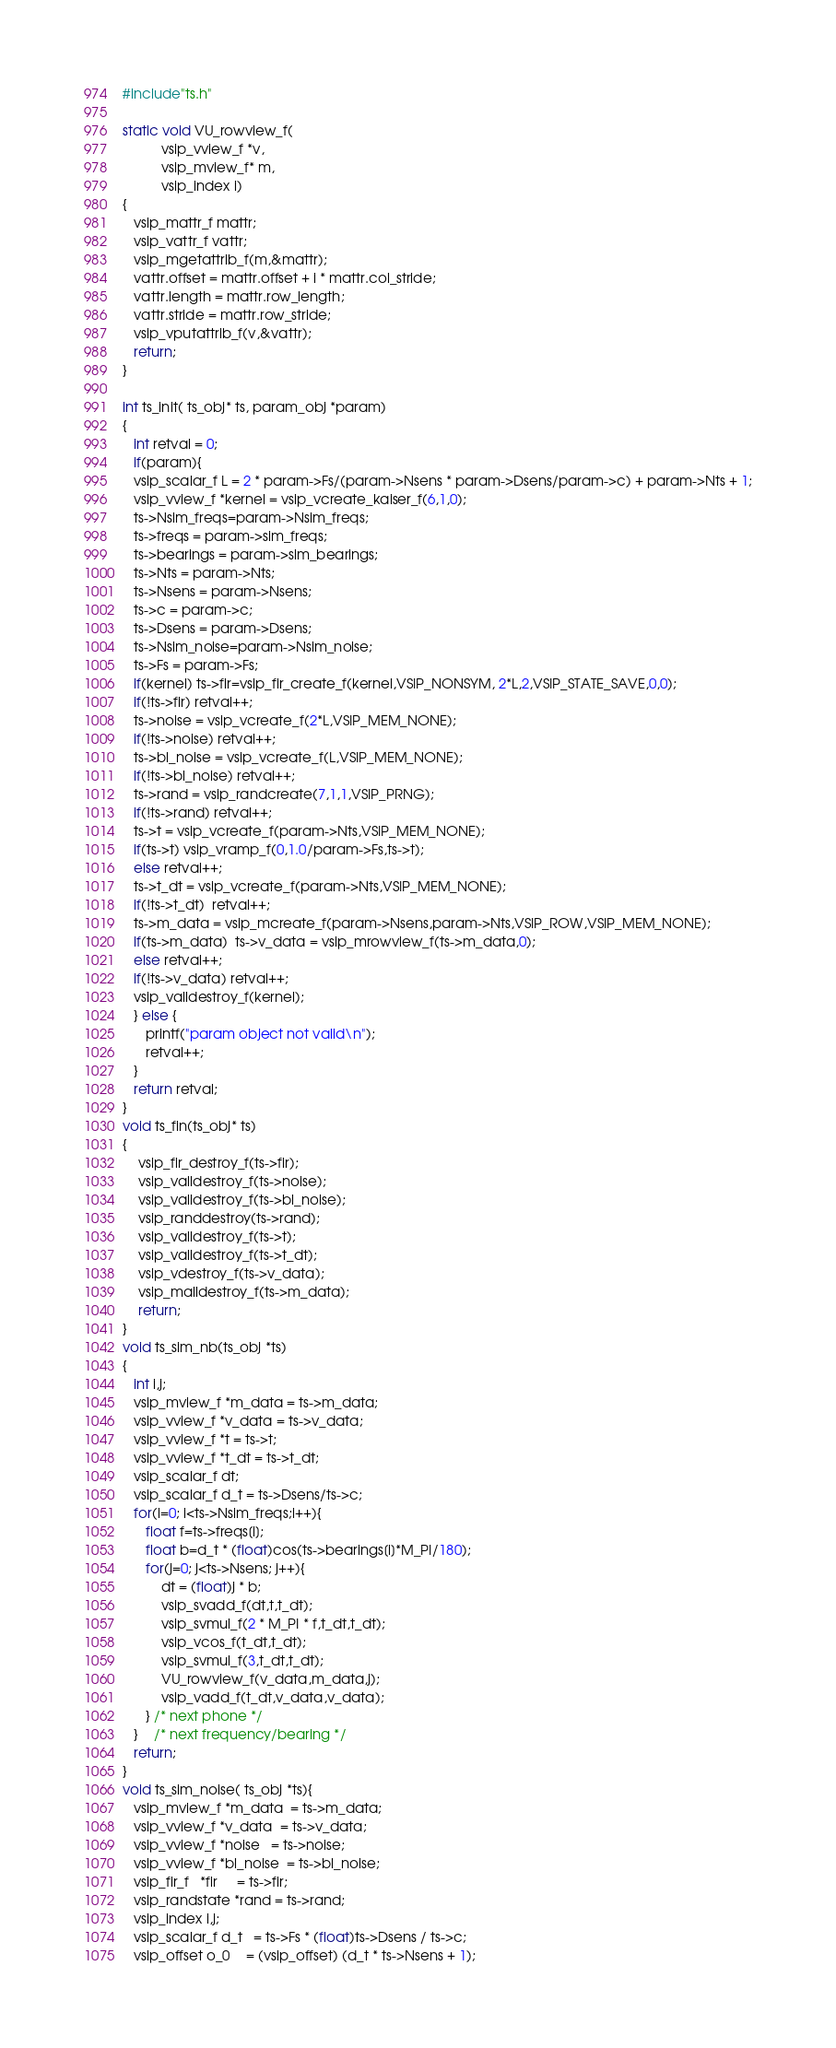Convert code to text. <code><loc_0><loc_0><loc_500><loc_500><_C_>#include"ts.h"

static void VU_rowview_f(
          vsip_vview_f *v, 
          vsip_mview_f* m, 
          vsip_index i)
{
   vsip_mattr_f mattr;
   vsip_vattr_f vattr;
   vsip_mgetattrib_f(m,&mattr);
   vattr.offset = mattr.offset + i * mattr.col_stride;
   vattr.length = mattr.row_length;
   vattr.stride = mattr.row_stride;
   vsip_vputattrib_f(v,&vattr);
   return;
}

int ts_init( ts_obj* ts, param_obj *param)
{
   int retval = 0;
   if(param){
   vsip_scalar_f L = 2 * param->Fs/(param->Nsens * param->Dsens/param->c) + param->Nts + 1;
   vsip_vview_f *kernel = vsip_vcreate_kaiser_f(6,1,0);
   ts->Nsim_freqs=param->Nsim_freqs;
   ts->freqs = param->sim_freqs;
   ts->bearings = param->sim_bearings;
   ts->Nts = param->Nts;
   ts->Nsens = param->Nsens;
   ts->c = param->c;
   ts->Dsens = param->Dsens;
   ts->Nsim_noise=param->Nsim_noise;
   ts->Fs = param->Fs;
   if(kernel) ts->fir=vsip_fir_create_f(kernel,VSIP_NONSYM, 2*L,2,VSIP_STATE_SAVE,0,0);
   if(!ts->fir) retval++;
   ts->noise = vsip_vcreate_f(2*L,VSIP_MEM_NONE);
   if(!ts->noise) retval++;
   ts->bl_noise = vsip_vcreate_f(L,VSIP_MEM_NONE);
   if(!ts->bl_noise) retval++;
   ts->rand = vsip_randcreate(7,1,1,VSIP_PRNG);
   if(!ts->rand) retval++;
   ts->t = vsip_vcreate_f(param->Nts,VSIP_MEM_NONE);
   if(ts->t) vsip_vramp_f(0,1.0/param->Fs,ts->t);
   else retval++;
   ts->t_dt = vsip_vcreate_f(param->Nts,VSIP_MEM_NONE);
   if(!ts->t_dt)  retval++;
   ts->m_data = vsip_mcreate_f(param->Nsens,param->Nts,VSIP_ROW,VSIP_MEM_NONE);
   if(ts->m_data)  ts->v_data = vsip_mrowview_f(ts->m_data,0);
   else retval++;
   if(!ts->v_data) retval++;
   vsip_valldestroy_f(kernel);
   } else {
      printf("param object not valid\n");
      retval++;
   }
   return retval;
}     
void ts_fin(ts_obj* ts)
{
    vsip_fir_destroy_f(ts->fir);
    vsip_valldestroy_f(ts->noise);
    vsip_valldestroy_f(ts->bl_noise);
    vsip_randdestroy(ts->rand);
    vsip_valldestroy_f(ts->t);
    vsip_valldestroy_f(ts->t_dt);
    vsip_vdestroy_f(ts->v_data);
    vsip_malldestroy_f(ts->m_data);
    return;
}
void ts_sim_nb(ts_obj *ts)
{
   int i,j;
   vsip_mview_f *m_data = ts->m_data;
   vsip_vview_f *v_data = ts->v_data;
   vsip_vview_f *t = ts->t;
   vsip_vview_f *t_dt = ts->t_dt;
   vsip_scalar_f dt;
   vsip_scalar_f d_t = ts->Dsens/ts->c;
   for(i=0; i<ts->Nsim_freqs;i++){
      float f=ts->freqs[i];
      float b=d_t * (float)cos(ts->bearings[i]*M_PI/180);
      for(j=0; j<ts->Nsens; j++){
          dt = (float)j * b;
          vsip_svadd_f(dt,t,t_dt);
          vsip_svmul_f(2 * M_PI * f,t_dt,t_dt);
          vsip_vcos_f(t_dt,t_dt);
          vsip_svmul_f(3,t_dt,t_dt);
          VU_rowview_f(v_data,m_data,j);
          vsip_vadd_f(t_dt,v_data,v_data);
      } /* next phone */
   }    /* next frequency/bearing */
   return;
}
void ts_sim_noise( ts_obj *ts){
   vsip_mview_f *m_data  = ts->m_data;
   vsip_vview_f *v_data  = ts->v_data;
   vsip_vview_f *noise   = ts->noise;
   vsip_vview_f *bl_noise  = ts->bl_noise;
   vsip_fir_f   *fir     = ts->fir;
   vsip_randstate *rand = ts->rand;
   vsip_index i,j;
   vsip_scalar_f d_t   = ts->Fs * (float)ts->Dsens / ts->c;
   vsip_offset o_0    = (vsip_offset) (d_t * ts->Nsens + 1);</code> 